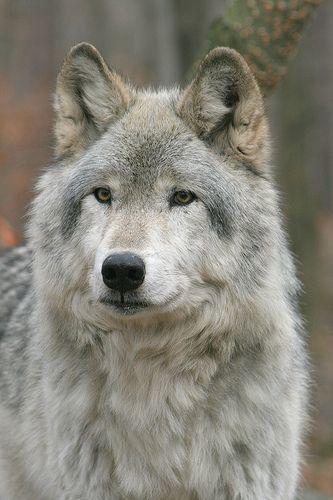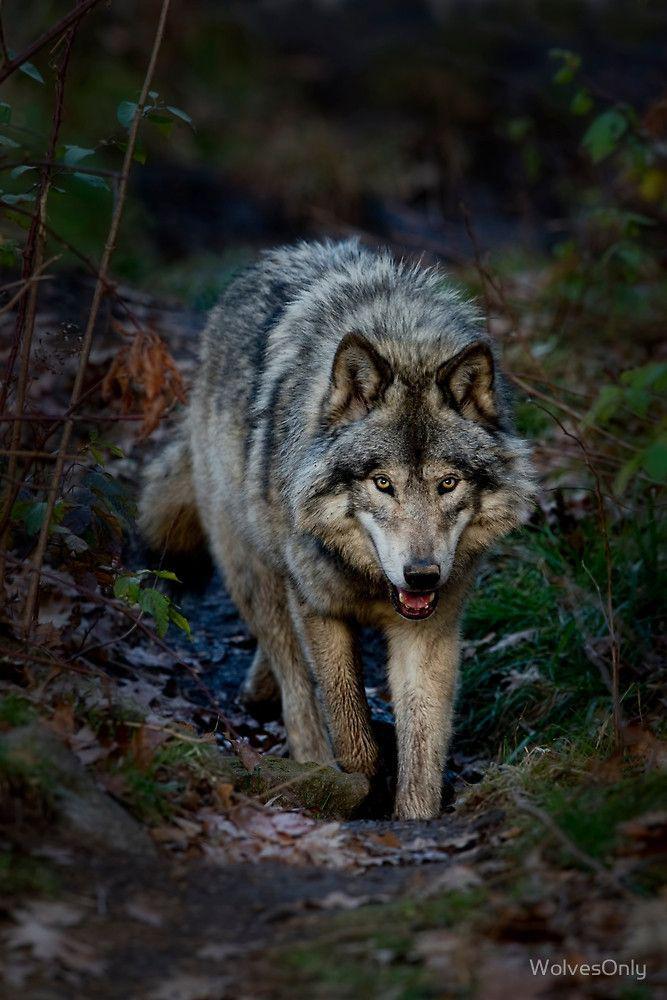The first image is the image on the left, the second image is the image on the right. Analyze the images presented: Is the assertion "Multiple wolves are depicted in the left image." valid? Answer yes or no. No. 